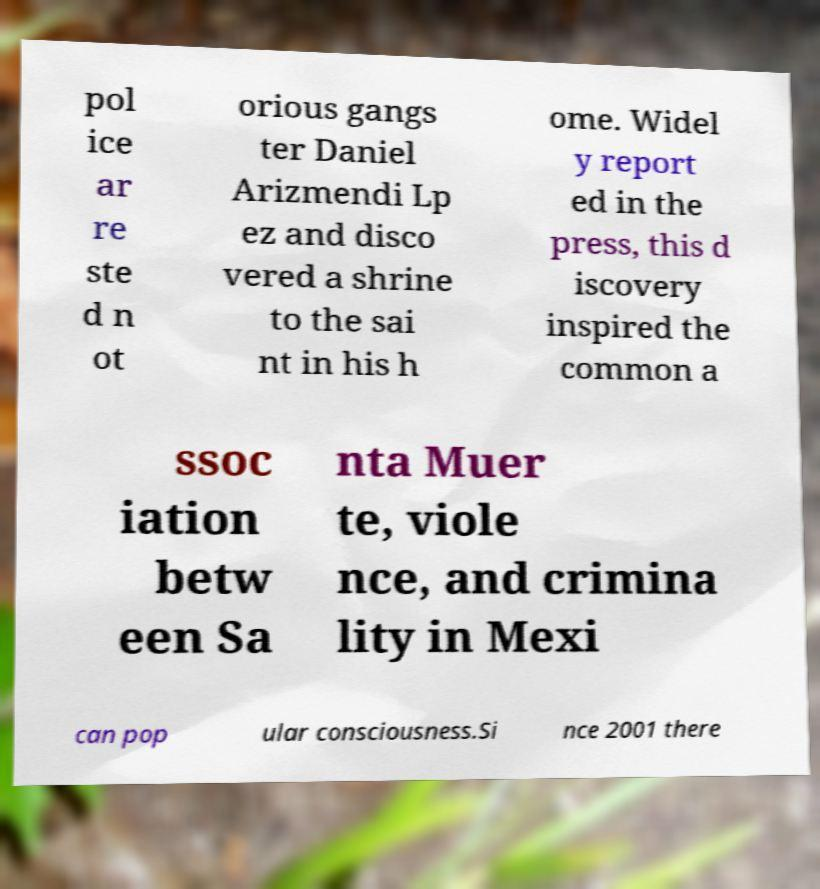Could you assist in decoding the text presented in this image and type it out clearly? pol ice ar re ste d n ot orious gangs ter Daniel Arizmendi Lp ez and disco vered a shrine to the sai nt in his h ome. Widel y report ed in the press, this d iscovery inspired the common a ssoc iation betw een Sa nta Muer te, viole nce, and crimina lity in Mexi can pop ular consciousness.Si nce 2001 there 